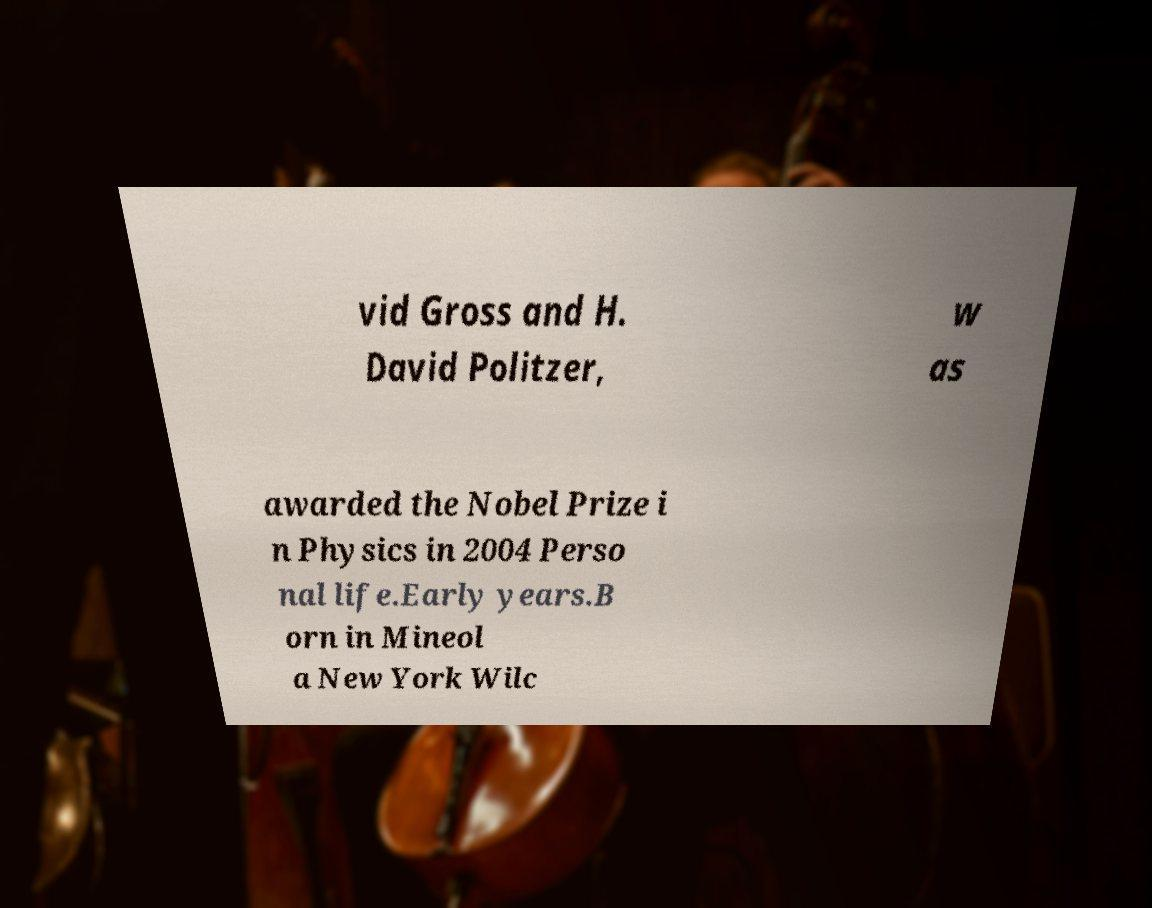What messages or text are displayed in this image? I need them in a readable, typed format. vid Gross and H. David Politzer, w as awarded the Nobel Prize i n Physics in 2004 Perso nal life.Early years.B orn in Mineol a New York Wilc 